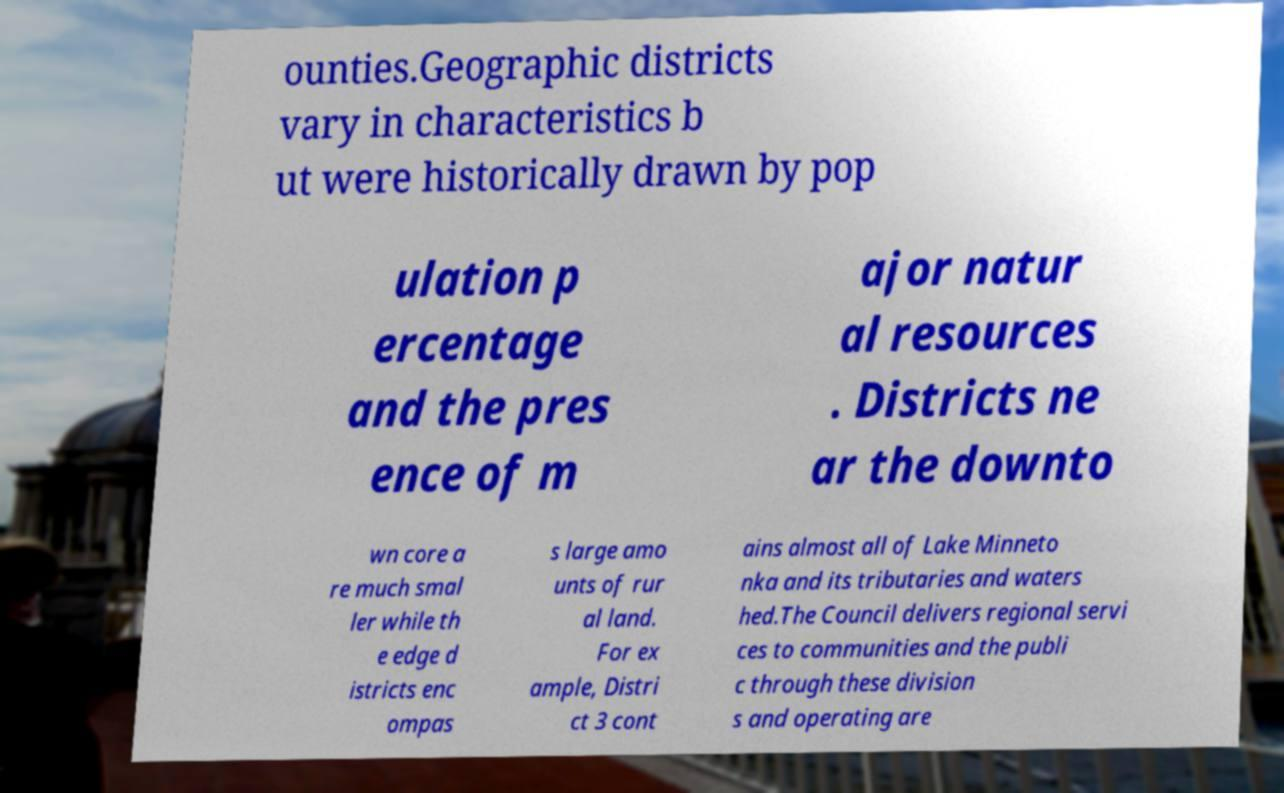Please identify and transcribe the text found in this image. ounties.Geographic districts vary in characteristics b ut were historically drawn by pop ulation p ercentage and the pres ence of m ajor natur al resources . Districts ne ar the downto wn core a re much smal ler while th e edge d istricts enc ompas s large amo unts of rur al land. For ex ample, Distri ct 3 cont ains almost all of Lake Minneto nka and its tributaries and waters hed.The Council delivers regional servi ces to communities and the publi c through these division s and operating are 